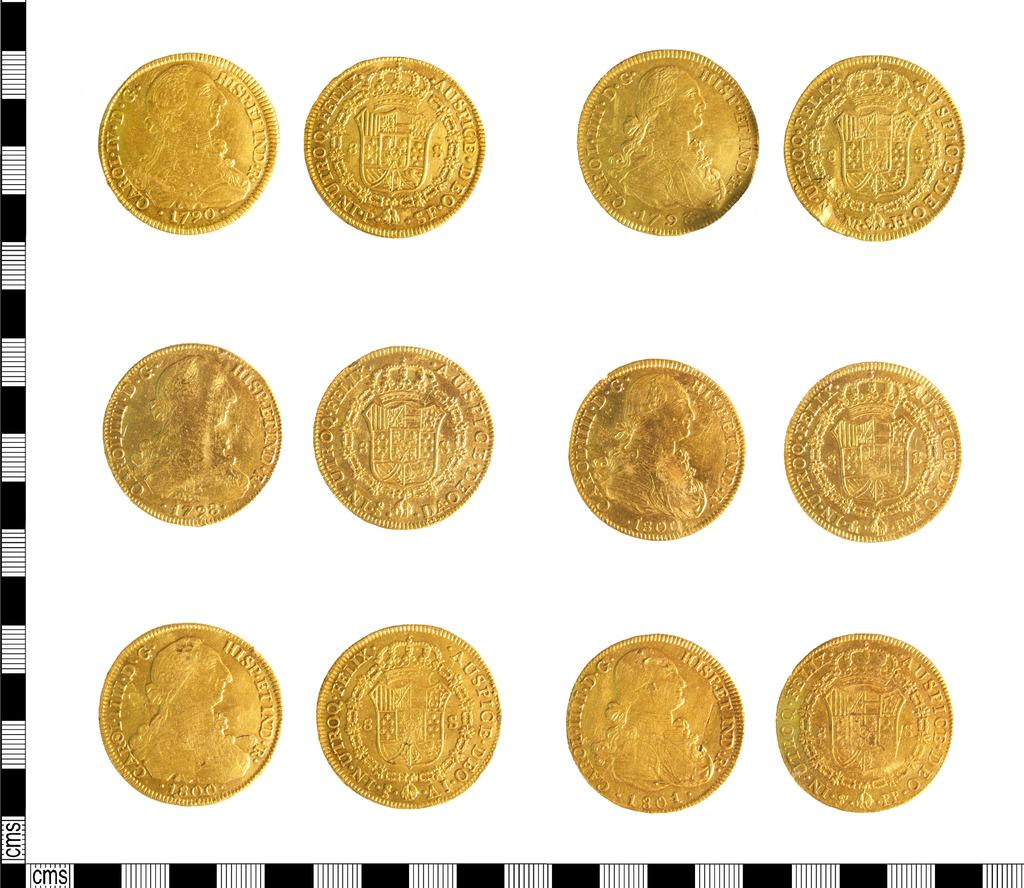<image>
Provide a brief description of the given image. Twelve gold coins on a white background with latin inscriptions. 